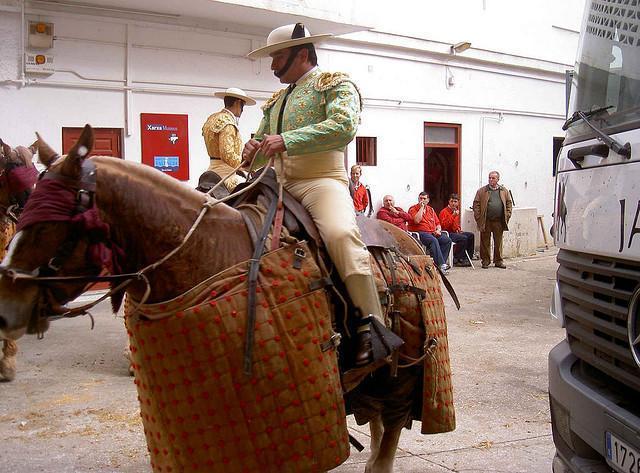How many men have red shirts?
Give a very brief answer. 4. How many people are there?
Give a very brief answer. 3. How many horses are in the photo?
Give a very brief answer. 2. How many bottle caps are in the photo?
Give a very brief answer. 0. 